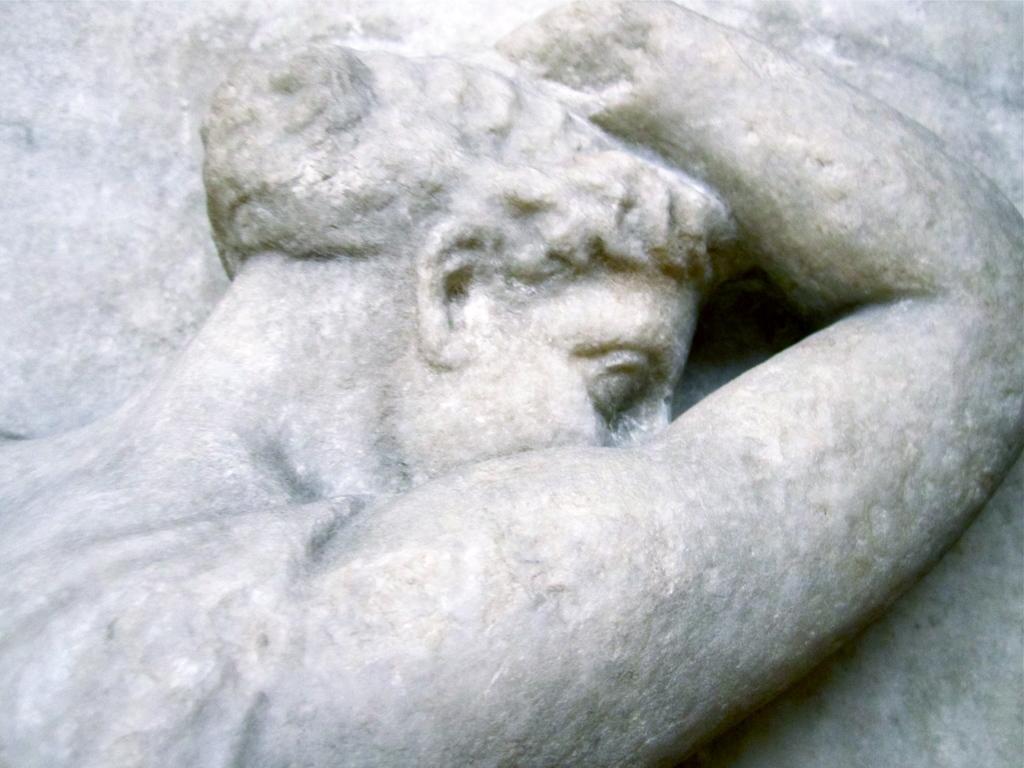Can you describe this image briefly? In this picture we can see the upper part of a human statue made of a rock. 